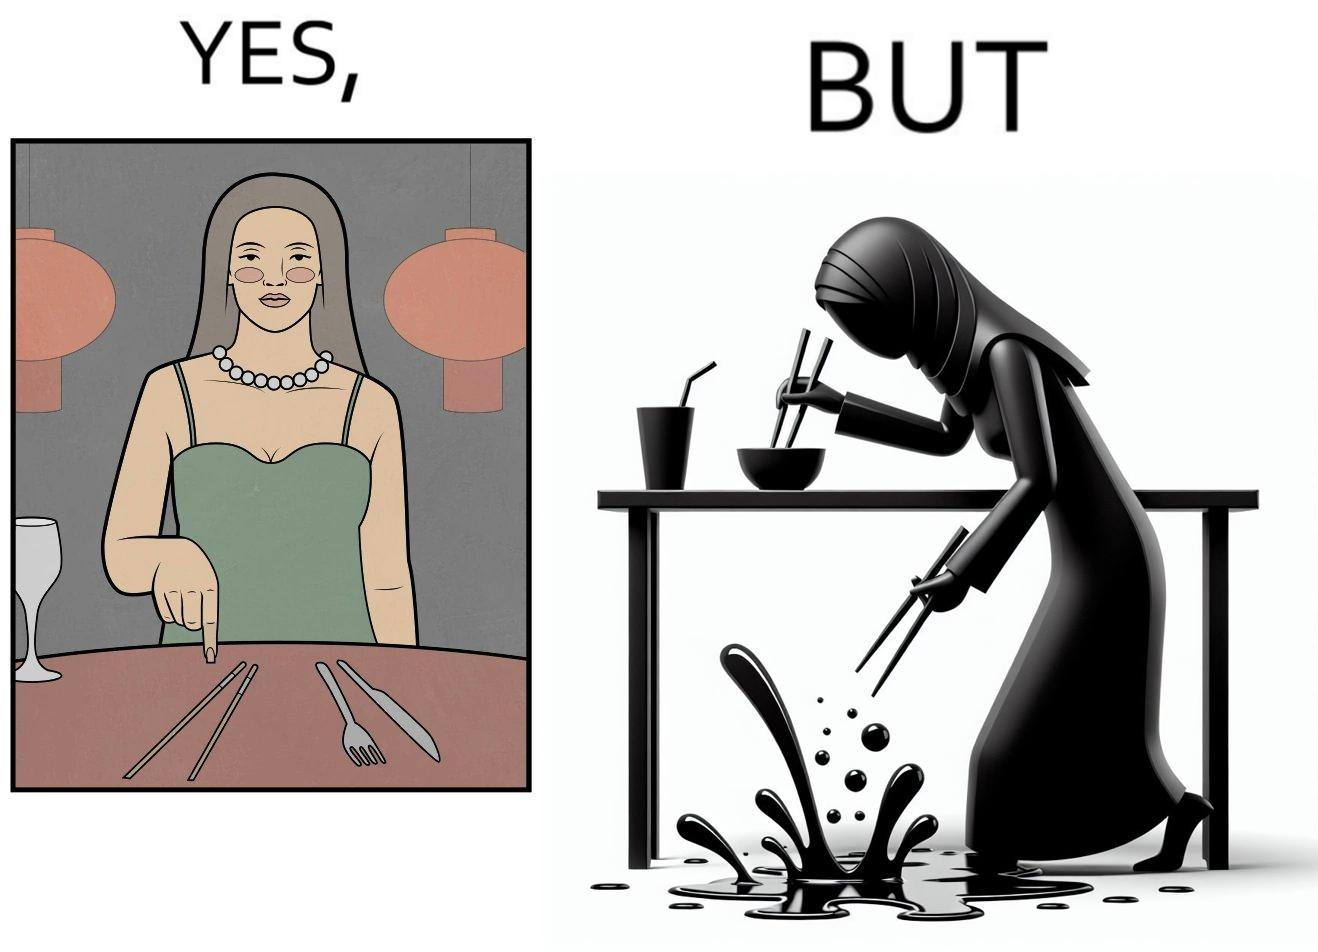Describe the contrast between the left and right parts of this image. In the left part of the image: The image shows a woman sitting at a table in a restaruant pointing to chopsticks on her table. There is also a wine glass, a fork and a knief on her table. In the right part of the image: The image shows a person using chopstick to pick up food from the cup. The person is not able to handle food with chopstick well and is dropping the food around the cup on the table. 